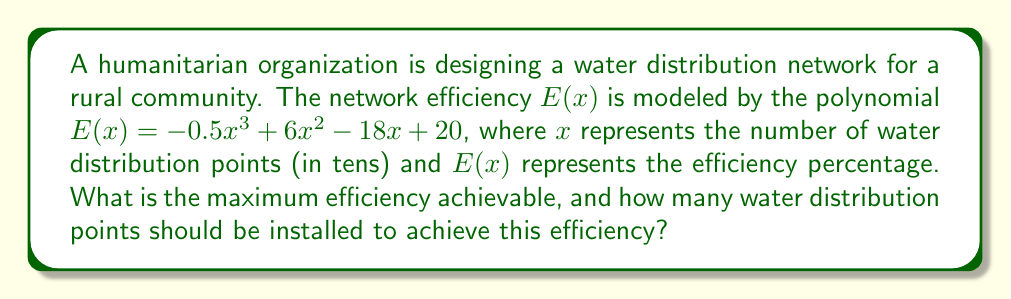Teach me how to tackle this problem. To find the maximum efficiency and the optimal number of water distribution points, we need to follow these steps:

1) First, we need to find the derivative of the efficiency function $E(x)$:
   $$E'(x) = -1.5x^2 + 12x - 18$$

2) To find the critical points, we set $E'(x) = 0$ and solve:
   $$-1.5x^2 + 12x - 18 = 0$$
   $$-3x^2 + 24x - 36 = 0$$
   $$-3(x^2 - 8x + 12) = 0$$
   $$-3(x - 6)(x - 2) = 0$$
   
   So, $x = 6$ or $x = 2$

3) We need to check these critical points and the endpoints of any reasonable domain (say, 0 to 10) to find the maximum:

   At $x = 0$: $E(0) = 20$
   At $x = 2$: $E(2) = -0.5(8) + 6(4) - 18(2) + 20 = 28$
   At $x = 6$: $E(6) = -0.5(216) + 6(36) - 18(6) + 20 = 38$
   At $x = 10$: $E(10) = -0.5(1000) + 6(100) - 18(10) + 20 = -280$

4) The maximum value occurs at $x = 6$, which corresponds to 60 water distribution points.

5) The maximum efficiency is $E(6) = 38\%$.
Answer: The maximum efficiency achievable is 38%, which can be achieved by installing 60 water distribution points. 